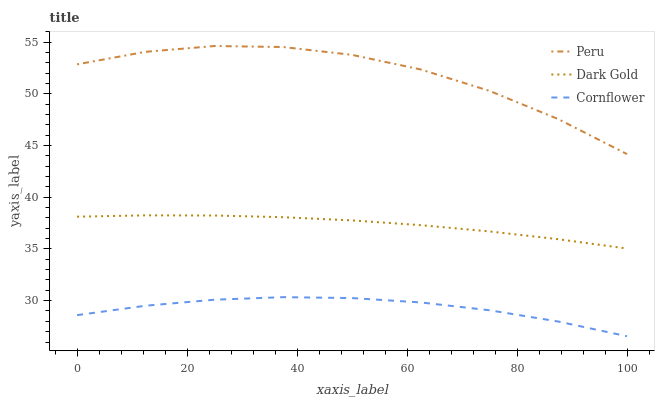Does Cornflower have the minimum area under the curve?
Answer yes or no. Yes. Does Peru have the maximum area under the curve?
Answer yes or no. Yes. Does Dark Gold have the minimum area under the curve?
Answer yes or no. No. Does Dark Gold have the maximum area under the curve?
Answer yes or no. No. Is Dark Gold the smoothest?
Answer yes or no. Yes. Is Peru the roughest?
Answer yes or no. Yes. Is Peru the smoothest?
Answer yes or no. No. Is Dark Gold the roughest?
Answer yes or no. No. Does Cornflower have the lowest value?
Answer yes or no. Yes. Does Dark Gold have the lowest value?
Answer yes or no. No. Does Peru have the highest value?
Answer yes or no. Yes. Does Dark Gold have the highest value?
Answer yes or no. No. Is Cornflower less than Dark Gold?
Answer yes or no. Yes. Is Dark Gold greater than Cornflower?
Answer yes or no. Yes. Does Cornflower intersect Dark Gold?
Answer yes or no. No. 